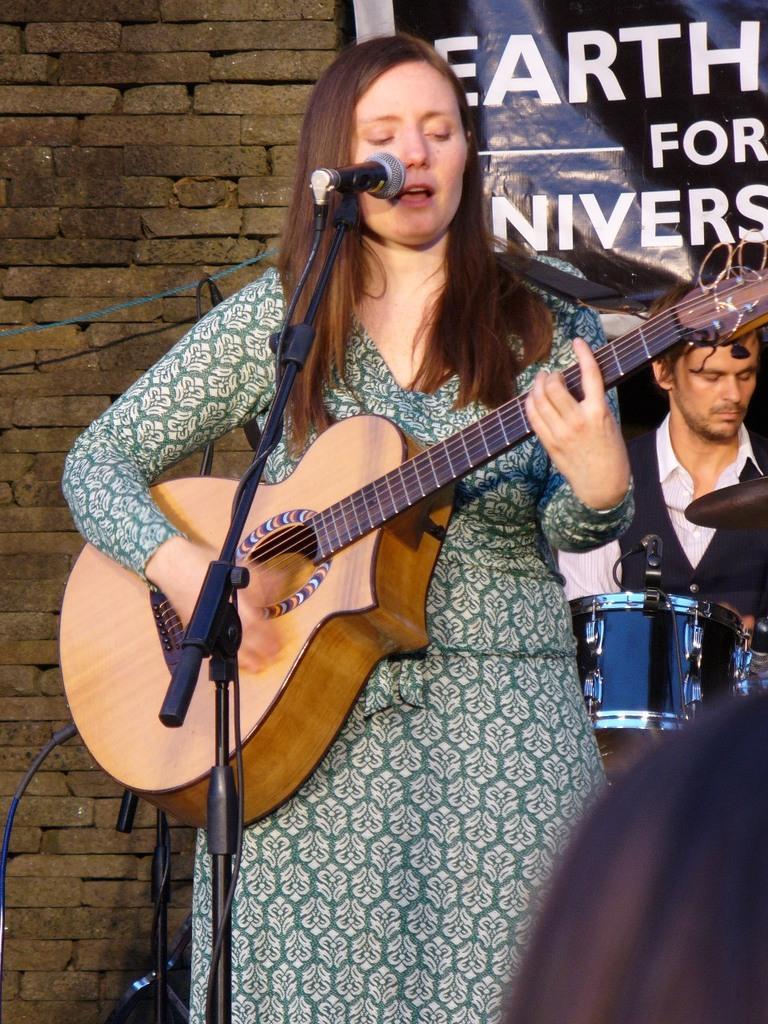In one or two sentences, can you explain what this image depicts? In the image a woman is standing and holding the guitar there is a mic in front of her, she is singing in the background there is a person who is playing drums and also a banner behind him and a brick wall. 